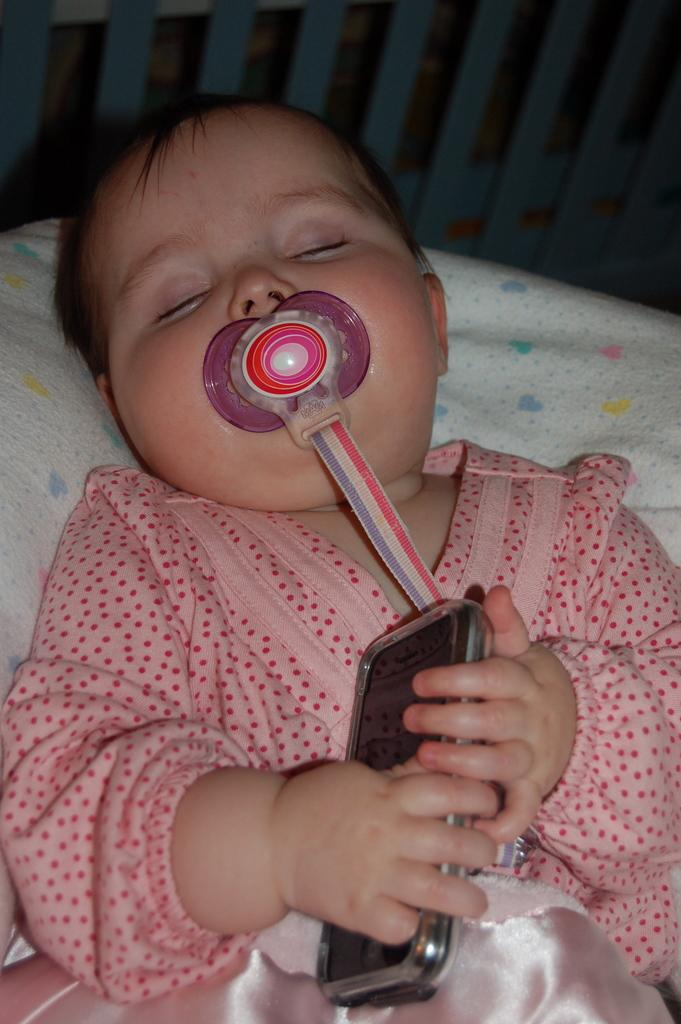What is the main subject of the image? The main subject of the image is a baby. What is the baby holding in the image? The baby is holding a mobile. What type of cracker is the baby eating in the image? There is no cracker present in the image; the baby is holding a mobile. Can you see a harbor in the background of the image? There is no information about a harbor in the image; it only shows a baby holding a mobile. 